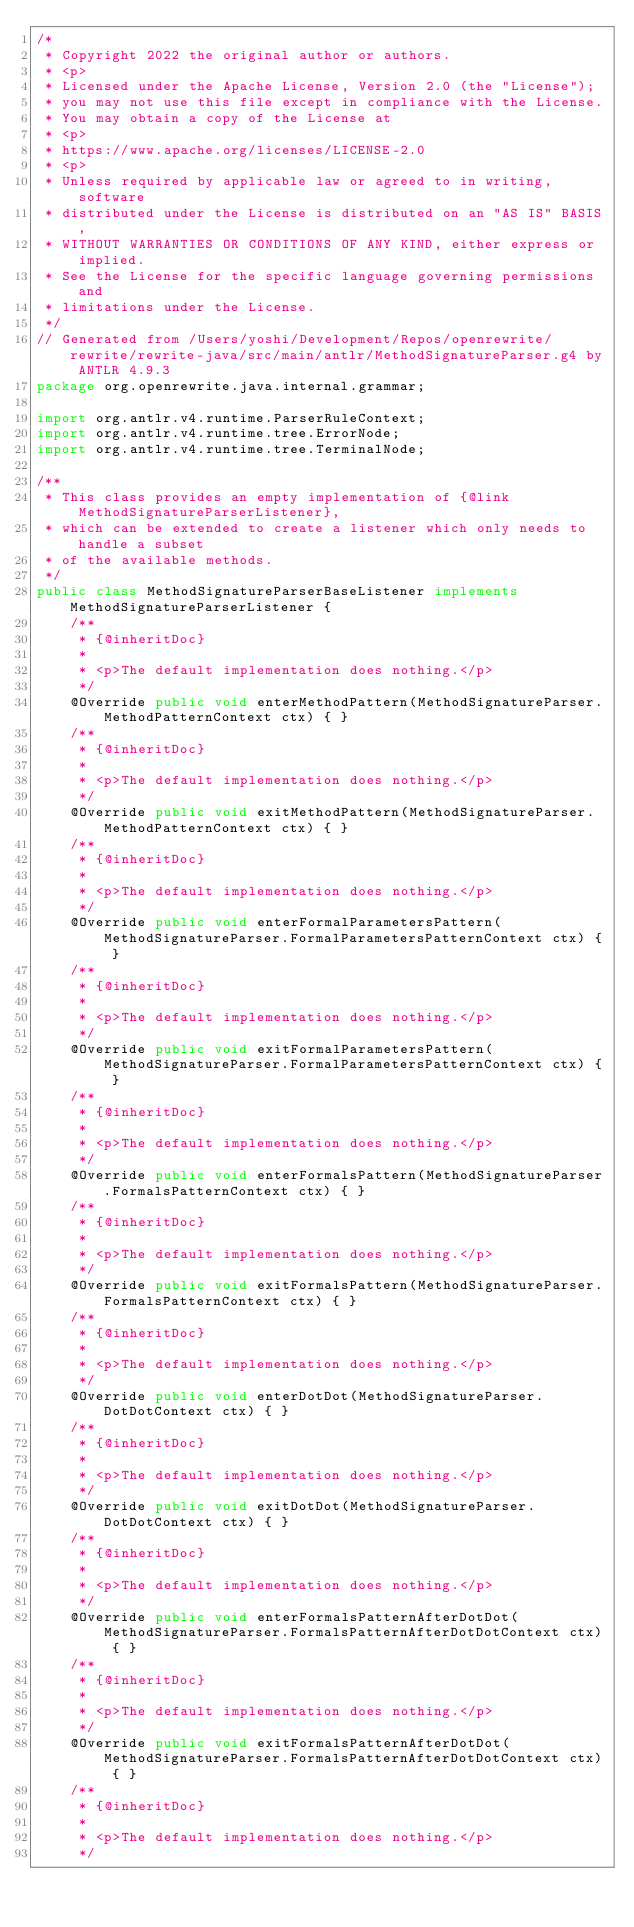Convert code to text. <code><loc_0><loc_0><loc_500><loc_500><_Java_>/*
 * Copyright 2022 the original author or authors.
 * <p>
 * Licensed under the Apache License, Version 2.0 (the "License");
 * you may not use this file except in compliance with the License.
 * You may obtain a copy of the License at
 * <p>
 * https://www.apache.org/licenses/LICENSE-2.0
 * <p>
 * Unless required by applicable law or agreed to in writing, software
 * distributed under the License is distributed on an "AS IS" BASIS,
 * WITHOUT WARRANTIES OR CONDITIONS OF ANY KIND, either express or implied.
 * See the License for the specific language governing permissions and
 * limitations under the License.
 */
// Generated from /Users/yoshi/Development/Repos/openrewrite/rewrite/rewrite-java/src/main/antlr/MethodSignatureParser.g4 by ANTLR 4.9.3
package org.openrewrite.java.internal.grammar;

import org.antlr.v4.runtime.ParserRuleContext;
import org.antlr.v4.runtime.tree.ErrorNode;
import org.antlr.v4.runtime.tree.TerminalNode;

/**
 * This class provides an empty implementation of {@link MethodSignatureParserListener},
 * which can be extended to create a listener which only needs to handle a subset
 * of the available methods.
 */
public class MethodSignatureParserBaseListener implements MethodSignatureParserListener {
	/**
	 * {@inheritDoc}
	 *
	 * <p>The default implementation does nothing.</p>
	 */
	@Override public void enterMethodPattern(MethodSignatureParser.MethodPatternContext ctx) { }
	/**
	 * {@inheritDoc}
	 *
	 * <p>The default implementation does nothing.</p>
	 */
	@Override public void exitMethodPattern(MethodSignatureParser.MethodPatternContext ctx) { }
	/**
	 * {@inheritDoc}
	 *
	 * <p>The default implementation does nothing.</p>
	 */
	@Override public void enterFormalParametersPattern(MethodSignatureParser.FormalParametersPatternContext ctx) { }
	/**
	 * {@inheritDoc}
	 *
	 * <p>The default implementation does nothing.</p>
	 */
	@Override public void exitFormalParametersPattern(MethodSignatureParser.FormalParametersPatternContext ctx) { }
	/**
	 * {@inheritDoc}
	 *
	 * <p>The default implementation does nothing.</p>
	 */
	@Override public void enterFormalsPattern(MethodSignatureParser.FormalsPatternContext ctx) { }
	/**
	 * {@inheritDoc}
	 *
	 * <p>The default implementation does nothing.</p>
	 */
	@Override public void exitFormalsPattern(MethodSignatureParser.FormalsPatternContext ctx) { }
	/**
	 * {@inheritDoc}
	 *
	 * <p>The default implementation does nothing.</p>
	 */
	@Override public void enterDotDot(MethodSignatureParser.DotDotContext ctx) { }
	/**
	 * {@inheritDoc}
	 *
	 * <p>The default implementation does nothing.</p>
	 */
	@Override public void exitDotDot(MethodSignatureParser.DotDotContext ctx) { }
	/**
	 * {@inheritDoc}
	 *
	 * <p>The default implementation does nothing.</p>
	 */
	@Override public void enterFormalsPatternAfterDotDot(MethodSignatureParser.FormalsPatternAfterDotDotContext ctx) { }
	/**
	 * {@inheritDoc}
	 *
	 * <p>The default implementation does nothing.</p>
	 */
	@Override public void exitFormalsPatternAfterDotDot(MethodSignatureParser.FormalsPatternAfterDotDotContext ctx) { }
	/**
	 * {@inheritDoc}
	 *
	 * <p>The default implementation does nothing.</p>
	 */</code> 